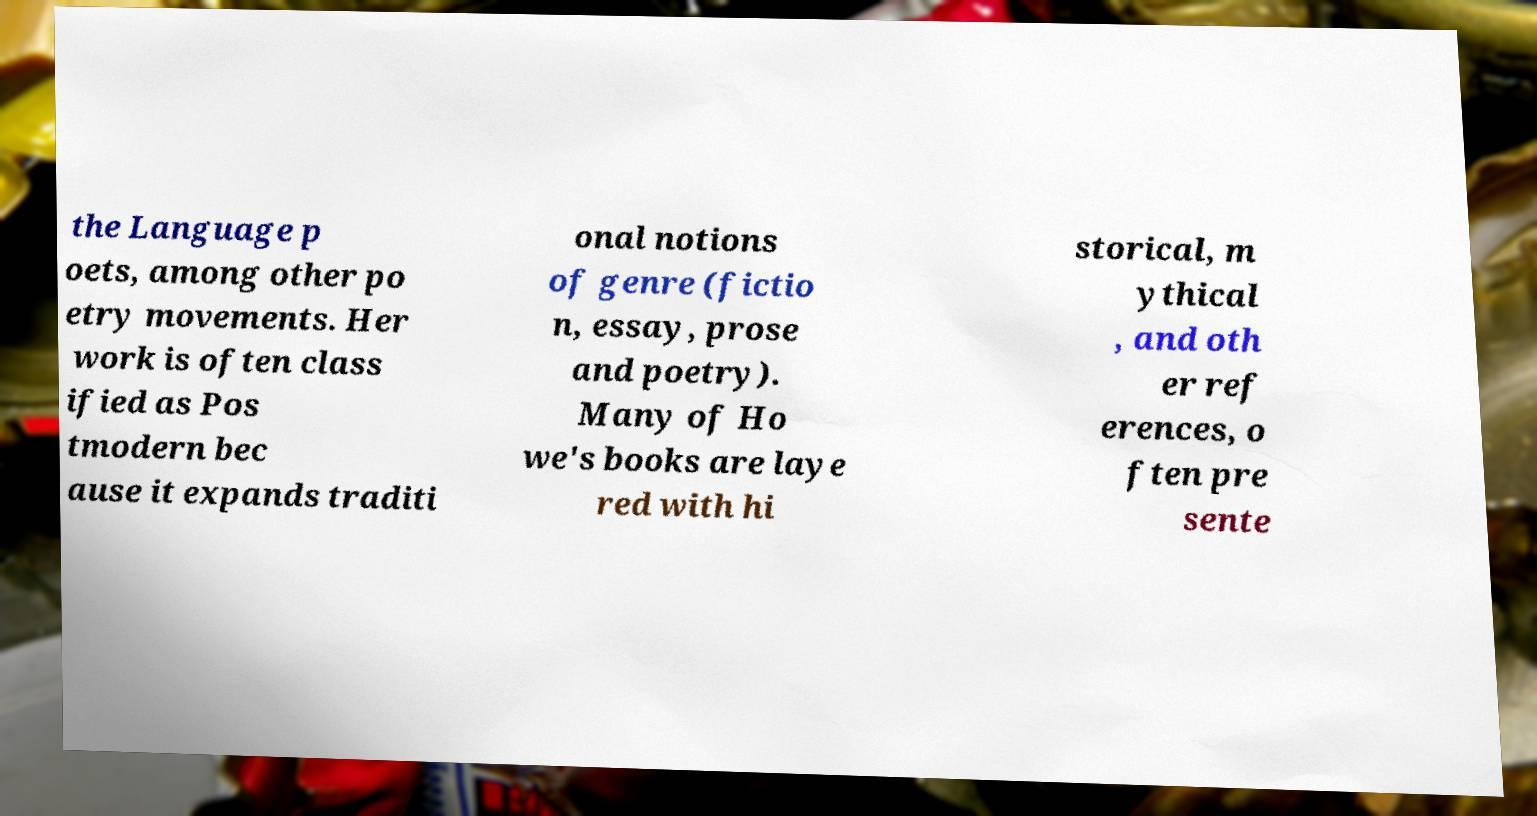Please identify and transcribe the text found in this image. the Language p oets, among other po etry movements. Her work is often class ified as Pos tmodern bec ause it expands traditi onal notions of genre (fictio n, essay, prose and poetry). Many of Ho we's books are laye red with hi storical, m ythical , and oth er ref erences, o ften pre sente 